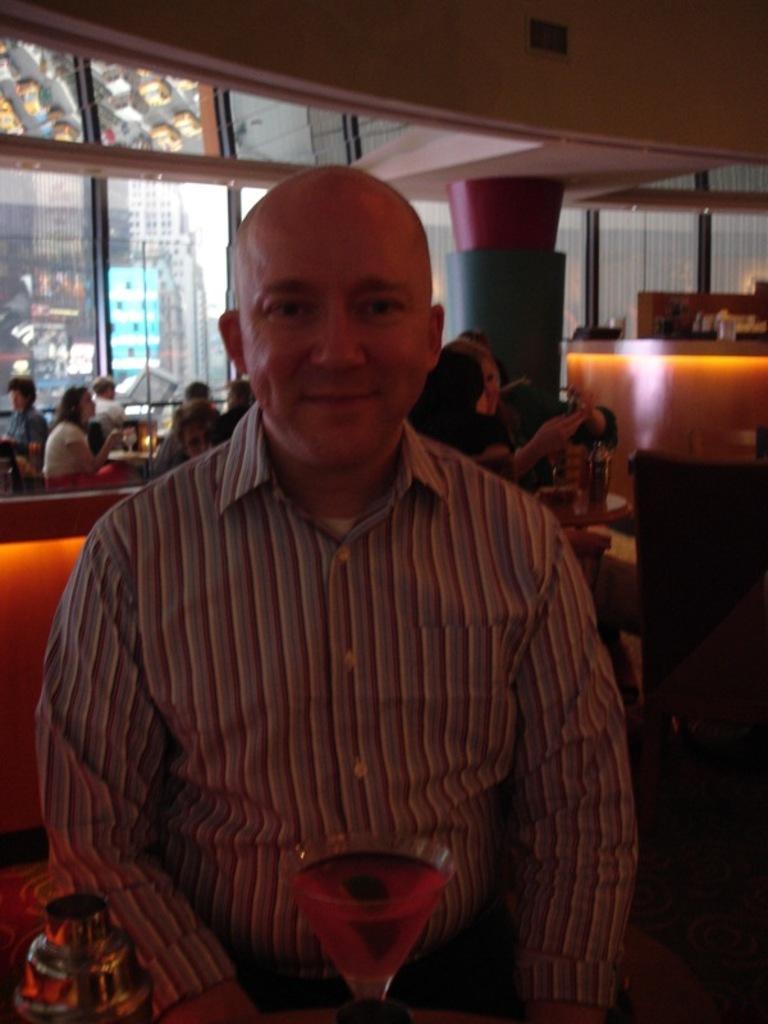Describe this image in one or two sentences. This is inside view picture. In this picture a man is sitting and smiling. In Front of him there is a glass with drink in it. Behind the man there are few persons sitting. At the right side of the picture we can see a reception. 